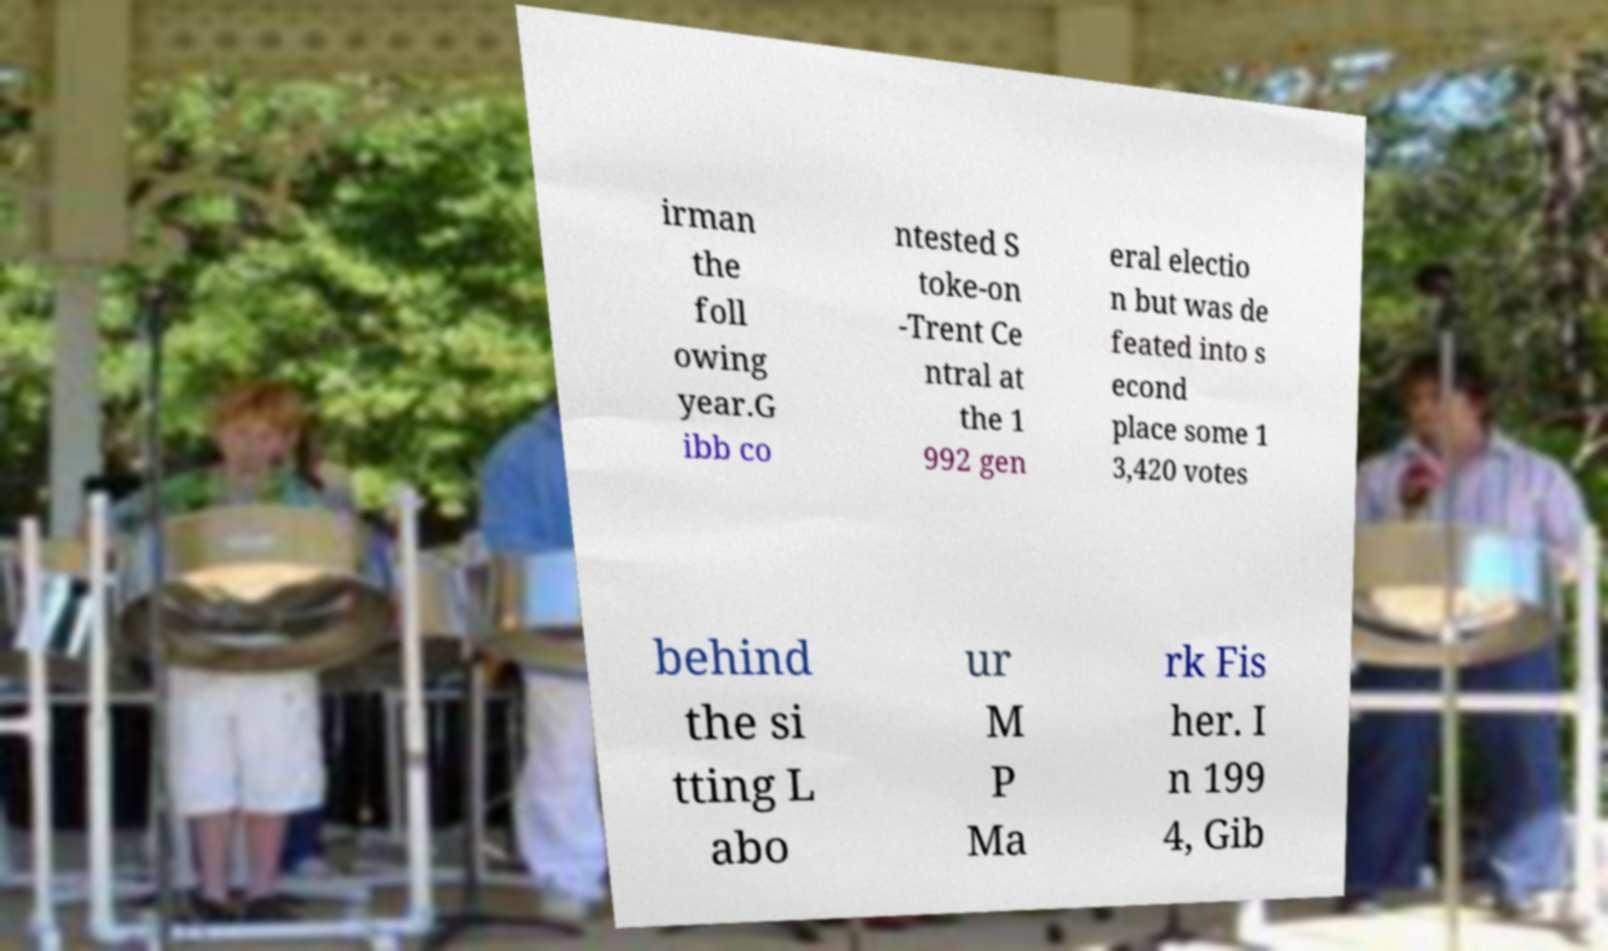Please read and relay the text visible in this image. What does it say? irman the foll owing year.G ibb co ntested S toke-on -Trent Ce ntral at the 1 992 gen eral electio n but was de feated into s econd place some 1 3,420 votes behind the si tting L abo ur M P Ma rk Fis her. I n 199 4, Gib 